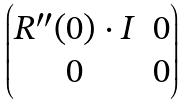<formula> <loc_0><loc_0><loc_500><loc_500>\begin{pmatrix} R ^ { \prime \prime } ( 0 ) \cdot I & 0 \\ 0 & 0 \end{pmatrix}</formula> 